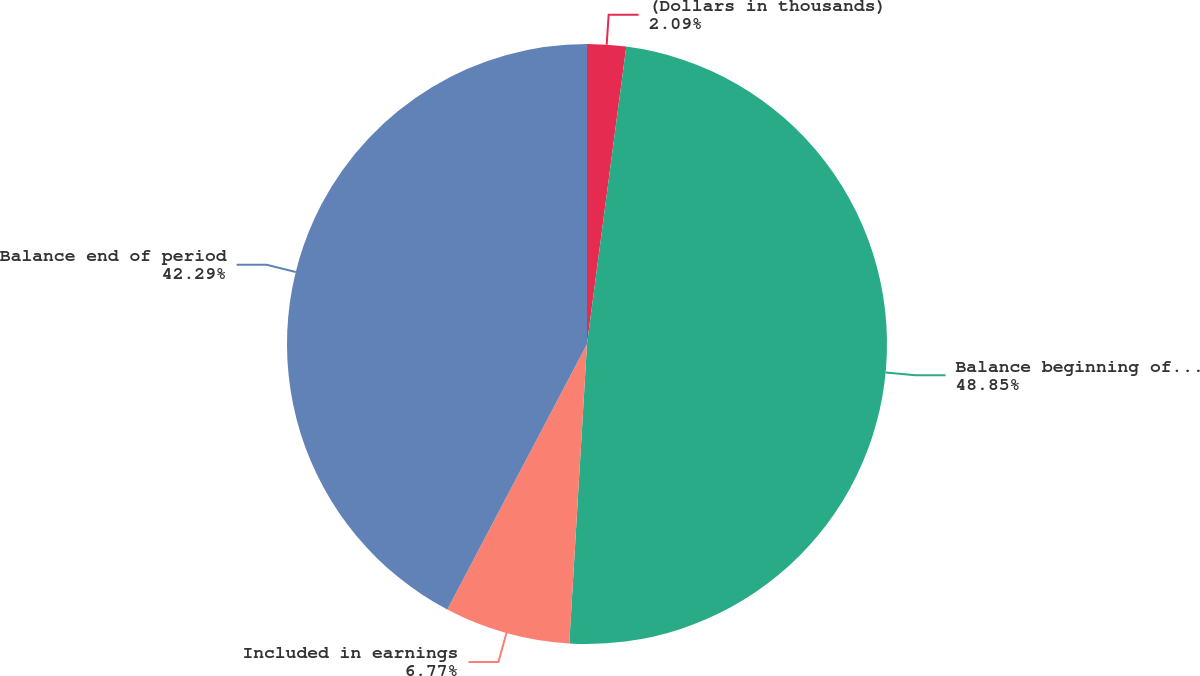Convert chart. <chart><loc_0><loc_0><loc_500><loc_500><pie_chart><fcel>(Dollars in thousands)<fcel>Balance beginning of period<fcel>Included in earnings<fcel>Balance end of period<nl><fcel>2.09%<fcel>48.85%<fcel>6.77%<fcel>42.29%<nl></chart> 